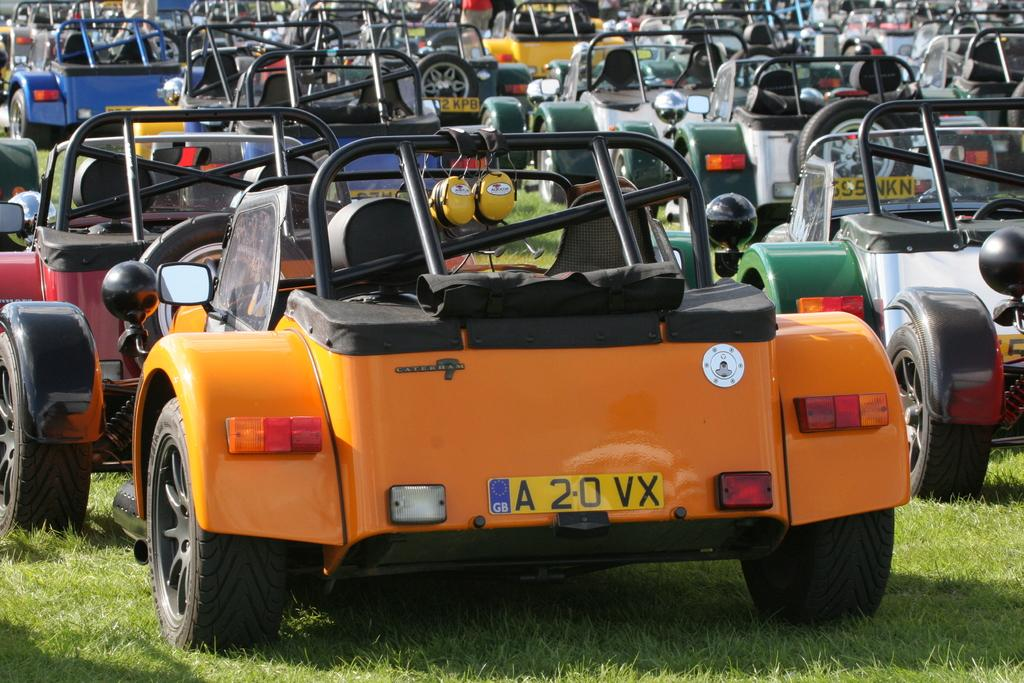What types of objects are present in the image? There are vehicles in the image. Where are the vehicles located? The vehicles are parked on the grass. What type of beam is supporting the vehicles in the image? There is no beam present in the image; the vehicles are parked on the grass. 